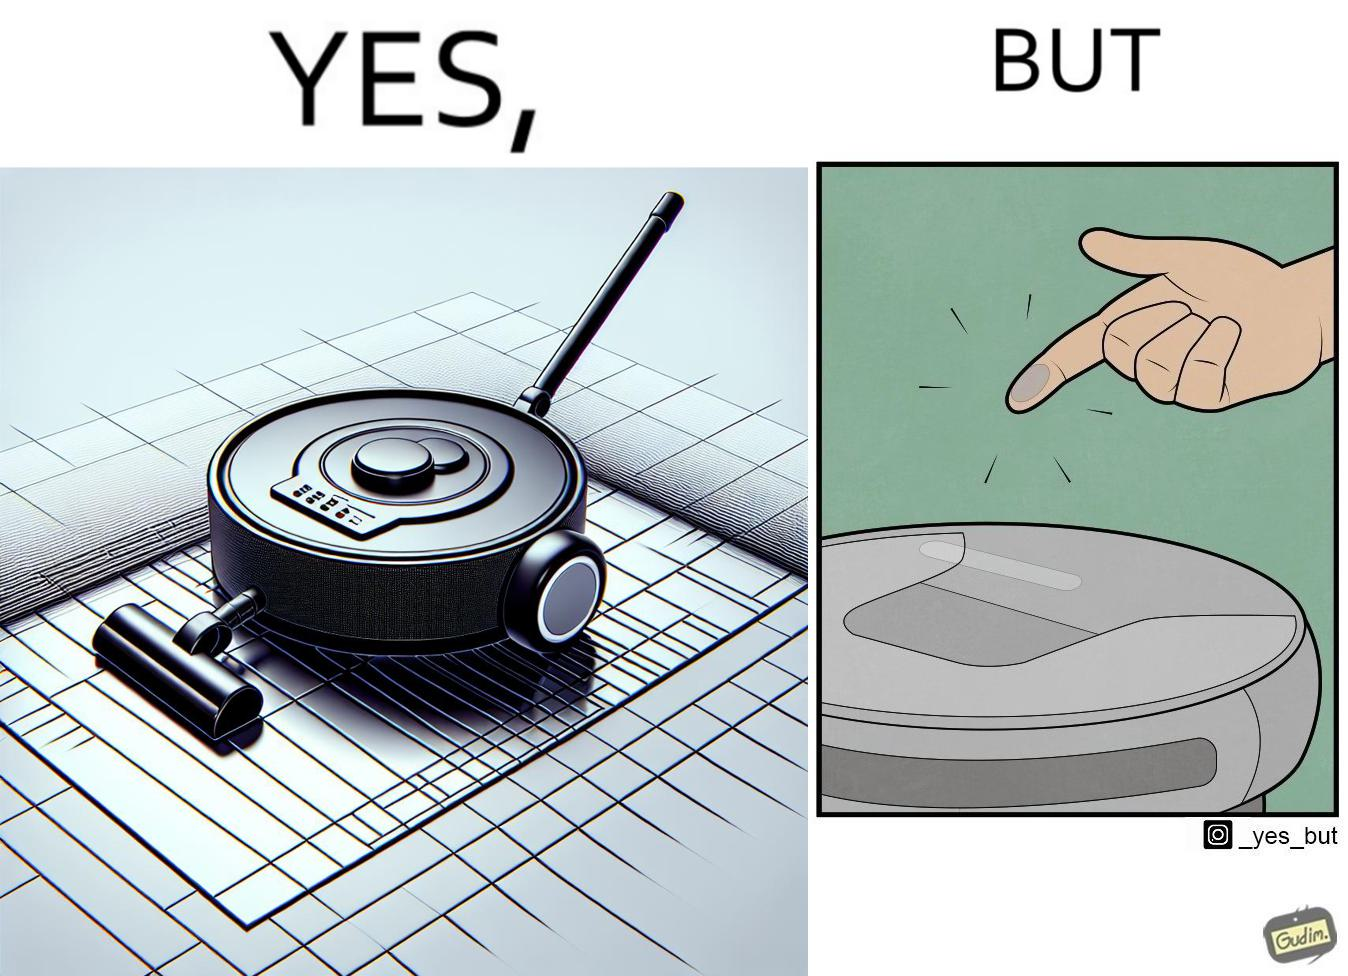What do you see in each half of this image? In the left part of the image: A vacuum cleaning machine that goes around the floor on its own and cleans the floor. Everything  around it looks squeaky clean, and is shining. In the right part of the image: Close up of a vacuum cleaning machine that goes around the floor on its own and cleans the floor. Everything  around it looks squeaky clean, and is shining, but it has a lot of dust on it except one line on it that looks clean. A persons fingertip is visible, and it is covered in dust. 